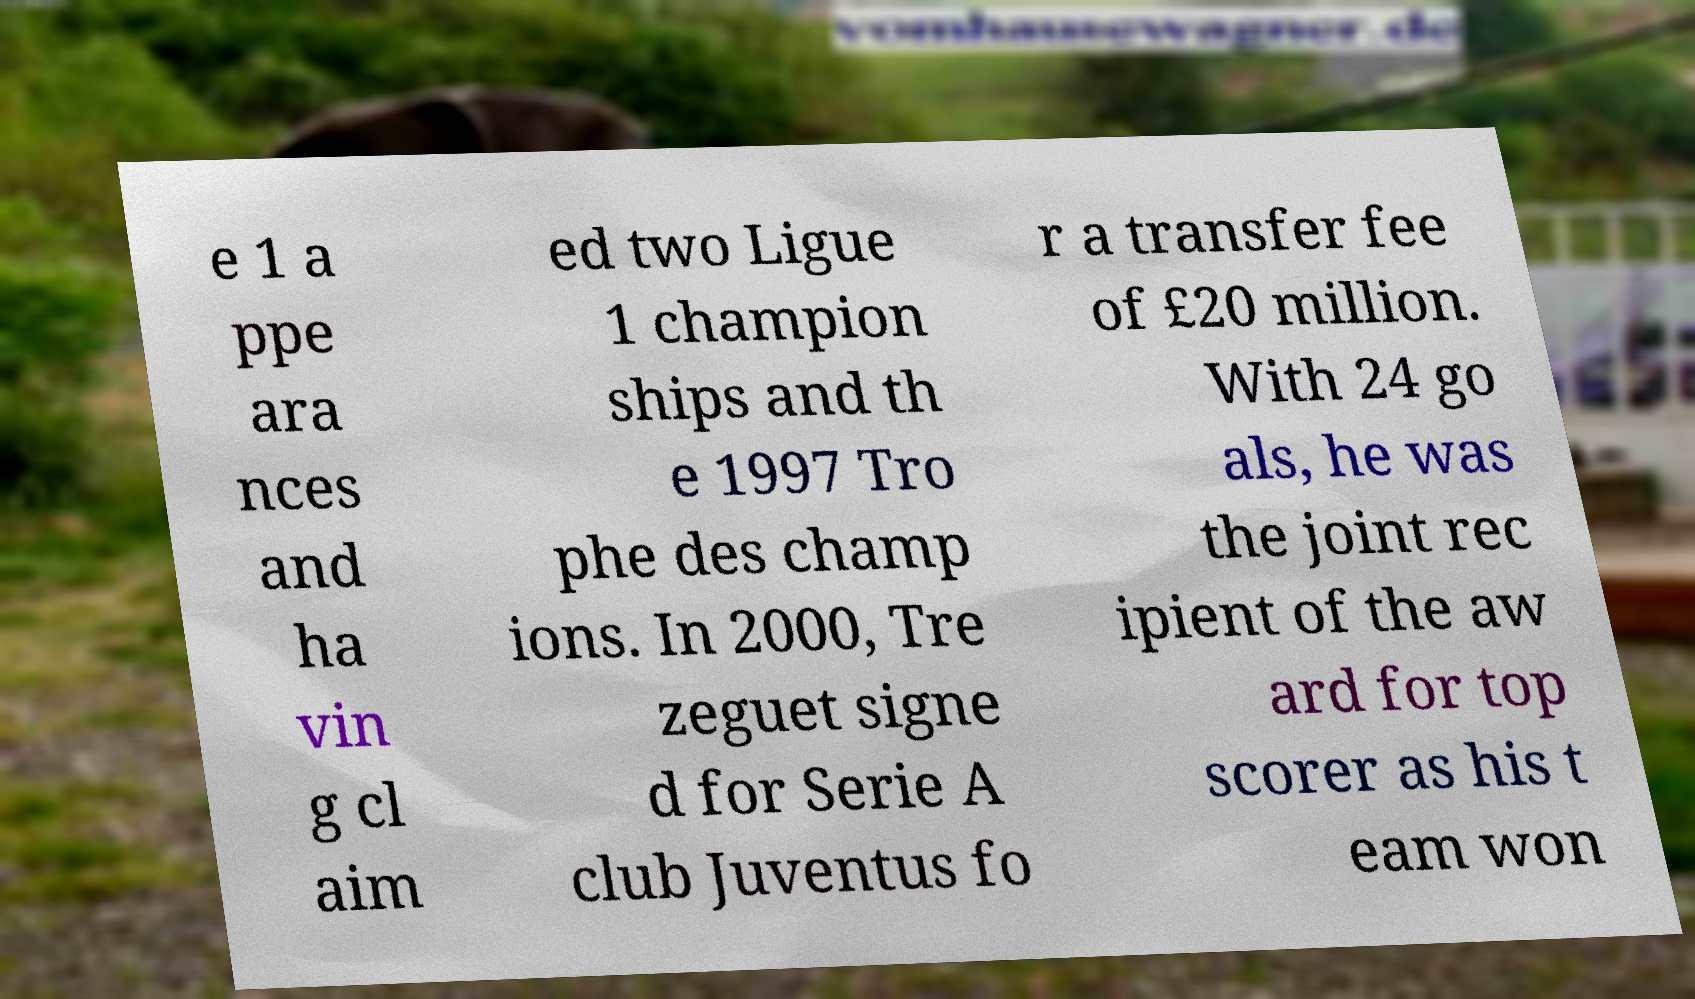Could you extract and type out the text from this image? e 1 a ppe ara nces and ha vin g cl aim ed two Ligue 1 champion ships and th e 1997 Tro phe des champ ions. In 2000, Tre zeguet signe d for Serie A club Juventus fo r a transfer fee of £20 million. With 24 go als, he was the joint rec ipient of the aw ard for top scorer as his t eam won 